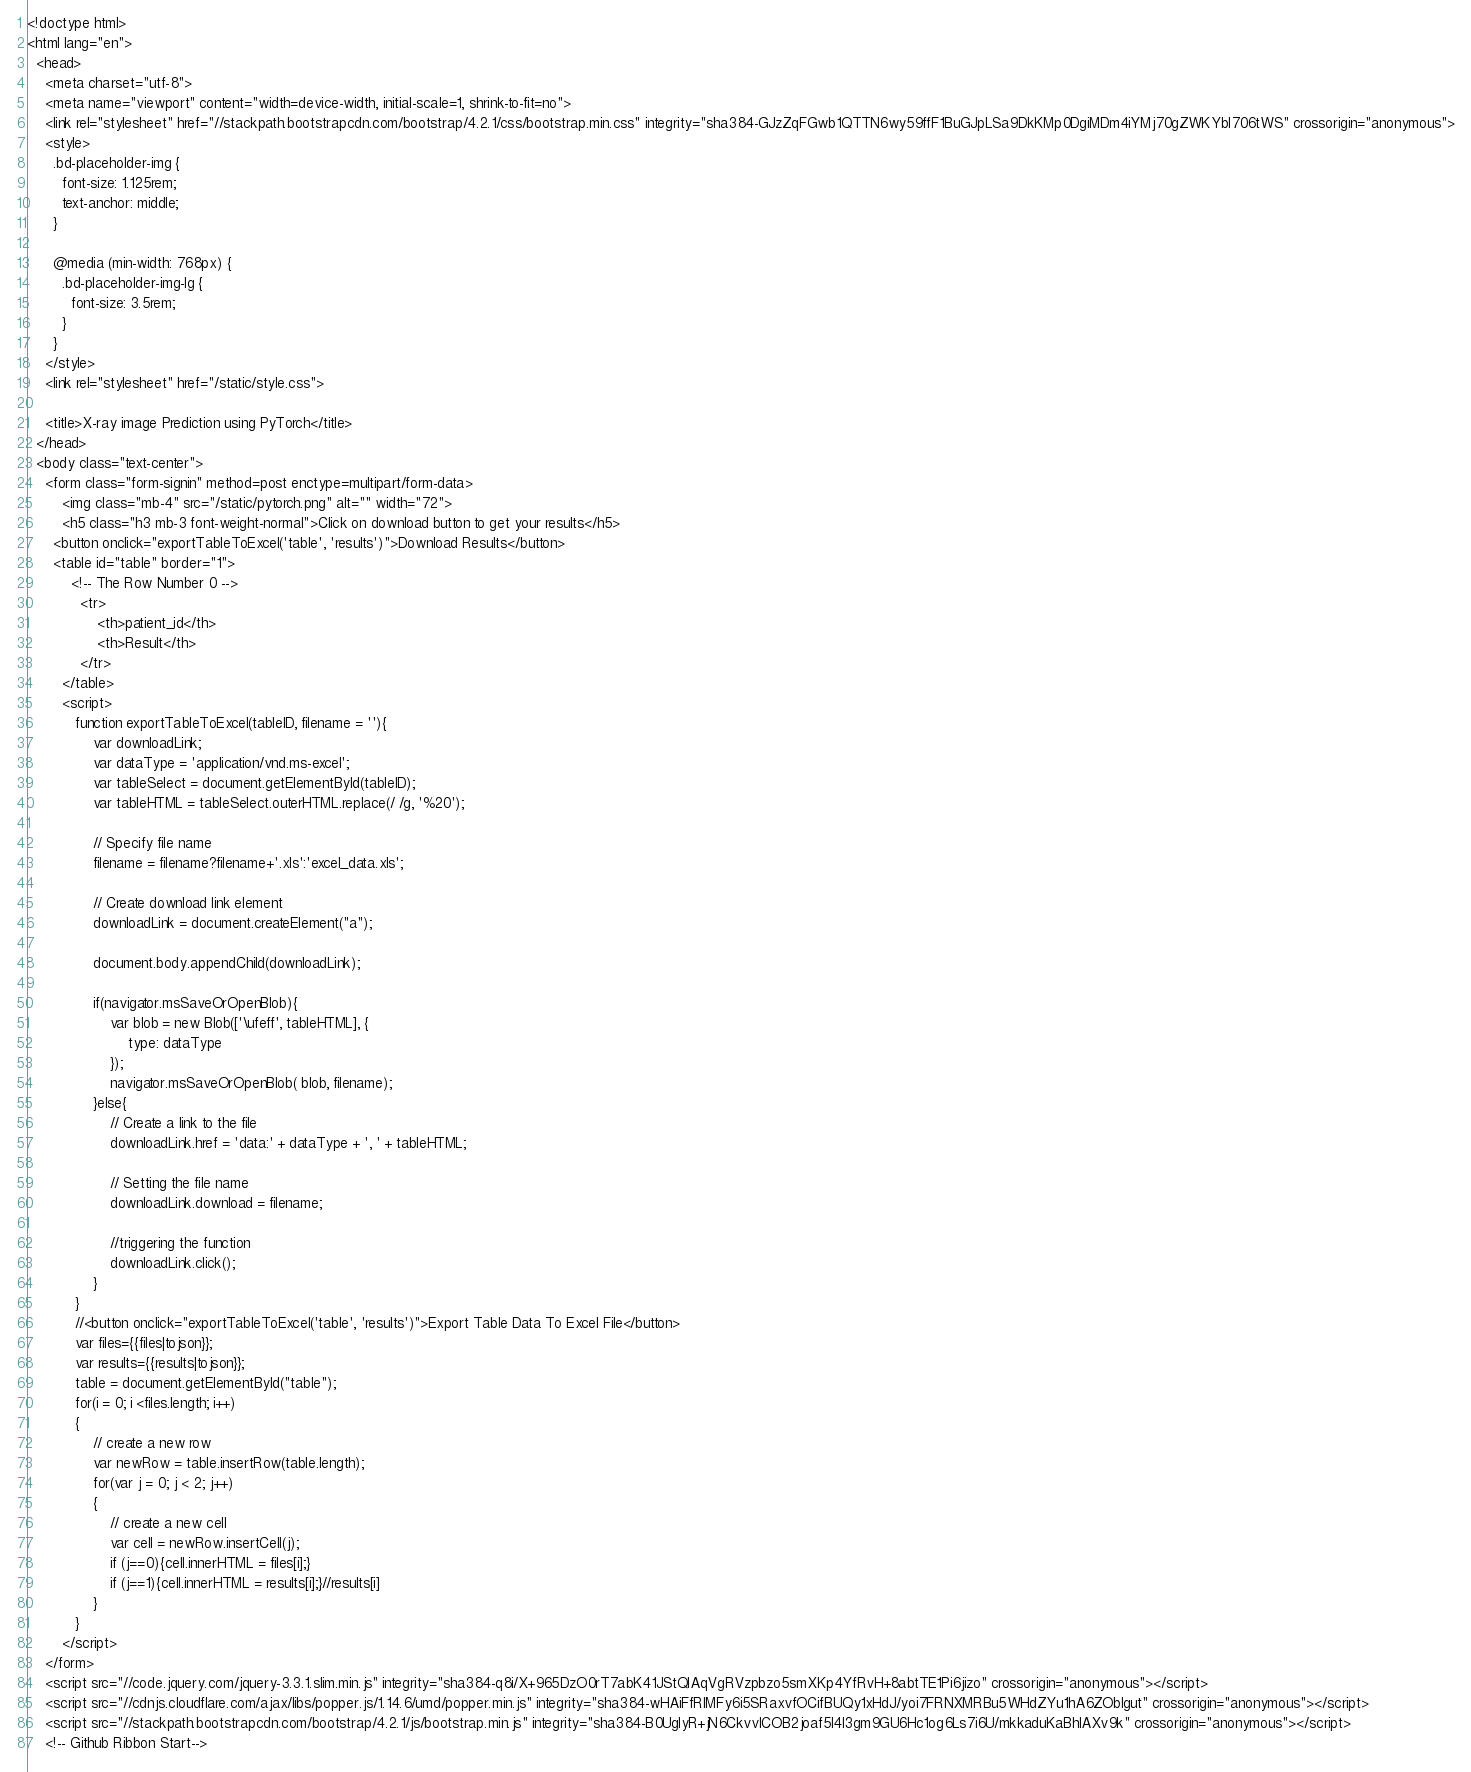Convert code to text. <code><loc_0><loc_0><loc_500><loc_500><_HTML_><!doctype html>
<html lang="en">
  <head>
    <meta charset="utf-8">
    <meta name="viewport" content="width=device-width, initial-scale=1, shrink-to-fit=no">
    <link rel="stylesheet" href="//stackpath.bootstrapcdn.com/bootstrap/4.2.1/css/bootstrap.min.css" integrity="sha384-GJzZqFGwb1QTTN6wy59ffF1BuGJpLSa9DkKMp0DgiMDm4iYMj70gZWKYbI706tWS" crossorigin="anonymous">
    <style>
      .bd-placeholder-img {
        font-size: 1.125rem;
        text-anchor: middle;
      }

      @media (min-width: 768px) {
        .bd-placeholder-img-lg {
          font-size: 3.5rem;
        }
      }
    </style>
    <link rel="stylesheet" href="/static/style.css">

    <title>X-ray image Prediction using PyTorch</title>
  </head>
  <body class="text-center">
    <form class="form-signin" method=post enctype=multipart/form-data>
        <img class="mb-4" src="/static/pytorch.png" alt="" width="72">
        <h5 class="h3 mb-3 font-weight-normal">Click on download button to get your results</h5>
      <button onclick="exportTableToExcel('table', 'results')">Download Results</button>  
      <table id="table" border="1">
          <!-- The Row Number 0 -->
            <tr>
                <th>patient_id</th>
                <th>Result</th>
            </tr>
        </table>
        <script>
           function exportTableToExcel(tableID, filename = ''){
               var downloadLink;
               var dataType = 'application/vnd.ms-excel';
               var tableSelect = document.getElementById(tableID);
               var tableHTML = tableSelect.outerHTML.replace(/ /g, '%20');

               // Specify file name
               filename = filename?filename+'.xls':'excel_data.xls';

               // Create download link element
               downloadLink = document.createElement("a");

               document.body.appendChild(downloadLink);

               if(navigator.msSaveOrOpenBlob){
                   var blob = new Blob(['\ufeff', tableHTML], {
                       type: dataType
                   });
                   navigator.msSaveOrOpenBlob( blob, filename);
               }else{
                   // Create a link to the file
                   downloadLink.href = 'data:' + dataType + ', ' + tableHTML;

                   // Setting the file name
                   downloadLink.download = filename;

                   //triggering the function
                   downloadLink.click();
               }
           } 
           //<button onclick="exportTableToExcel('table', 'results')">Export Table Data To Excel File</button>
           var files={{files|tojson}};
           var results={{results|tojson}};
           table = document.getElementById("table");
           for(i = 0; i <files.length; i++)
           {
               // create a new row
               var newRow = table.insertRow(table.length);
               for(var j = 0; j < 2; j++)
               {
                   // create a new cell
                   var cell = newRow.insertCell(j);
                   if (j==0){cell.innerHTML = files[i];}
                   if (j==1){cell.innerHTML = results[i];}//results[i]
               }
           }
        </script>   
    </form>   
    <script src="//code.jquery.com/jquery-3.3.1.slim.min.js" integrity="sha384-q8i/X+965DzO0rT7abK41JStQIAqVgRVzpbzo5smXKp4YfRvH+8abtTE1Pi6jizo" crossorigin="anonymous"></script>
    <script src="//cdnjs.cloudflare.com/ajax/libs/popper.js/1.14.6/umd/popper.min.js" integrity="sha384-wHAiFfRlMFy6i5SRaxvfOCifBUQy1xHdJ/yoi7FRNXMRBu5WHdZYu1hA6ZOblgut" crossorigin="anonymous"></script>
    <script src="//stackpath.bootstrapcdn.com/bootstrap/4.2.1/js/bootstrap.min.js" integrity="sha384-B0UglyR+jN6CkvvICOB2joaf5I4l3gm9GU6Hc1og6Ls7i6U/mkkaduKaBhlAXv9k" crossorigin="anonymous"></script>
    <!-- Github Ribbon Start--></code> 